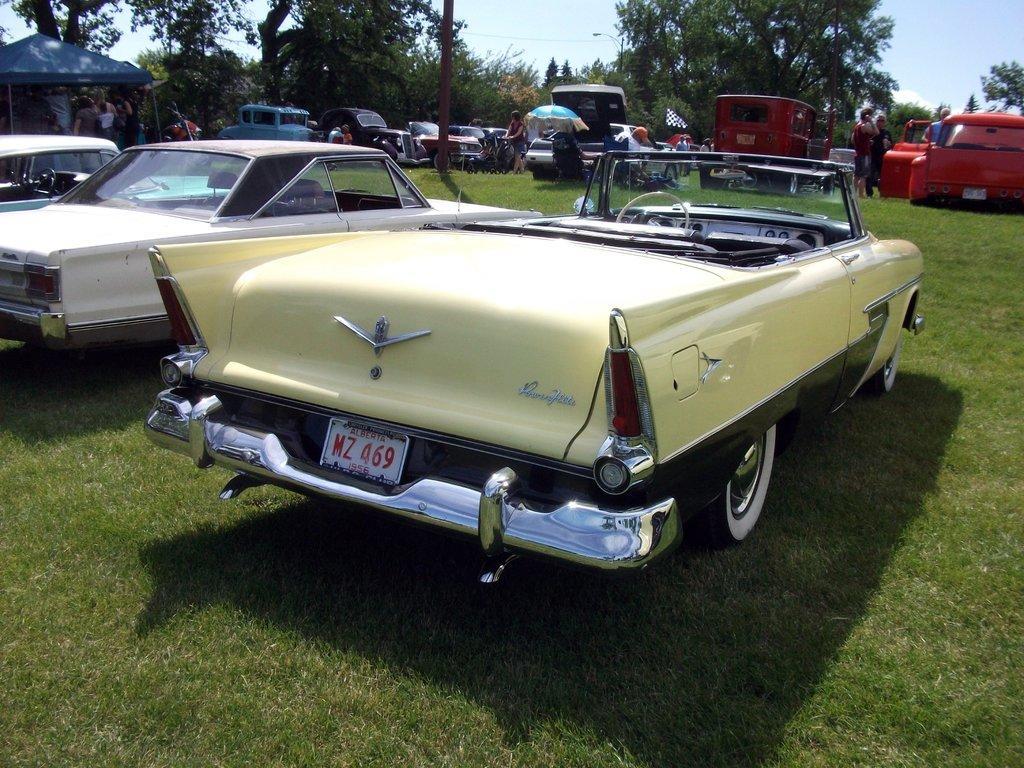Describe this image in one or two sentences. In this picture we can see vehicles, people, grass on the ground, here we can see a tent, umbrella, flag, street light, iron pole and some objects and in the background we can see trees, sky. 